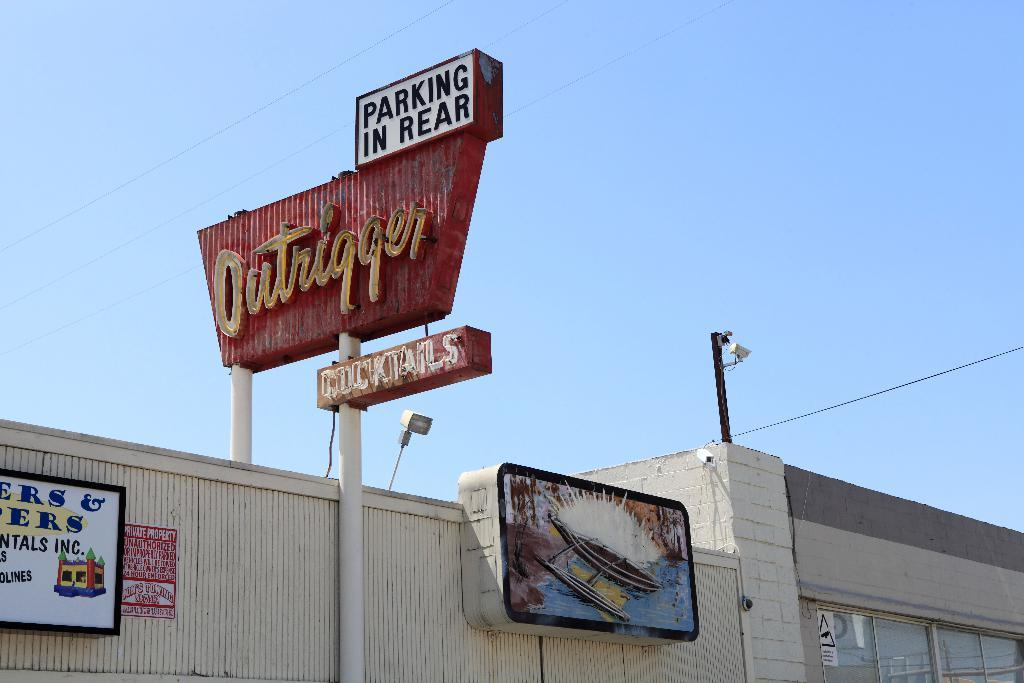<image>
Offer a succinct explanation of the picture presented. The Outrigger bar has cocktails and Parking In Rear. 